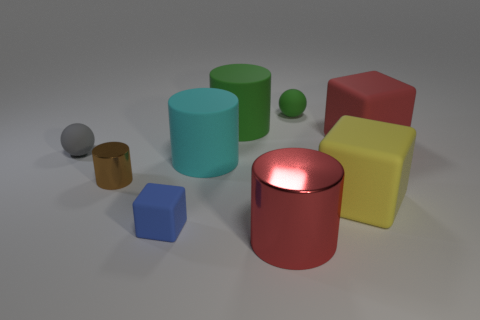Subtract all big red matte cubes. How many cubes are left? 2 Subtract all gray spheres. How many spheres are left? 1 Add 1 tiny metal blocks. How many objects exist? 10 Subtract 0 brown spheres. How many objects are left? 9 Subtract all spheres. How many objects are left? 7 Subtract 1 cylinders. How many cylinders are left? 3 Subtract all green blocks. Subtract all yellow balls. How many blocks are left? 3 Subtract all blue cylinders. How many yellow balls are left? 0 Subtract all tiny metallic balls. Subtract all large green cylinders. How many objects are left? 8 Add 7 cubes. How many cubes are left? 10 